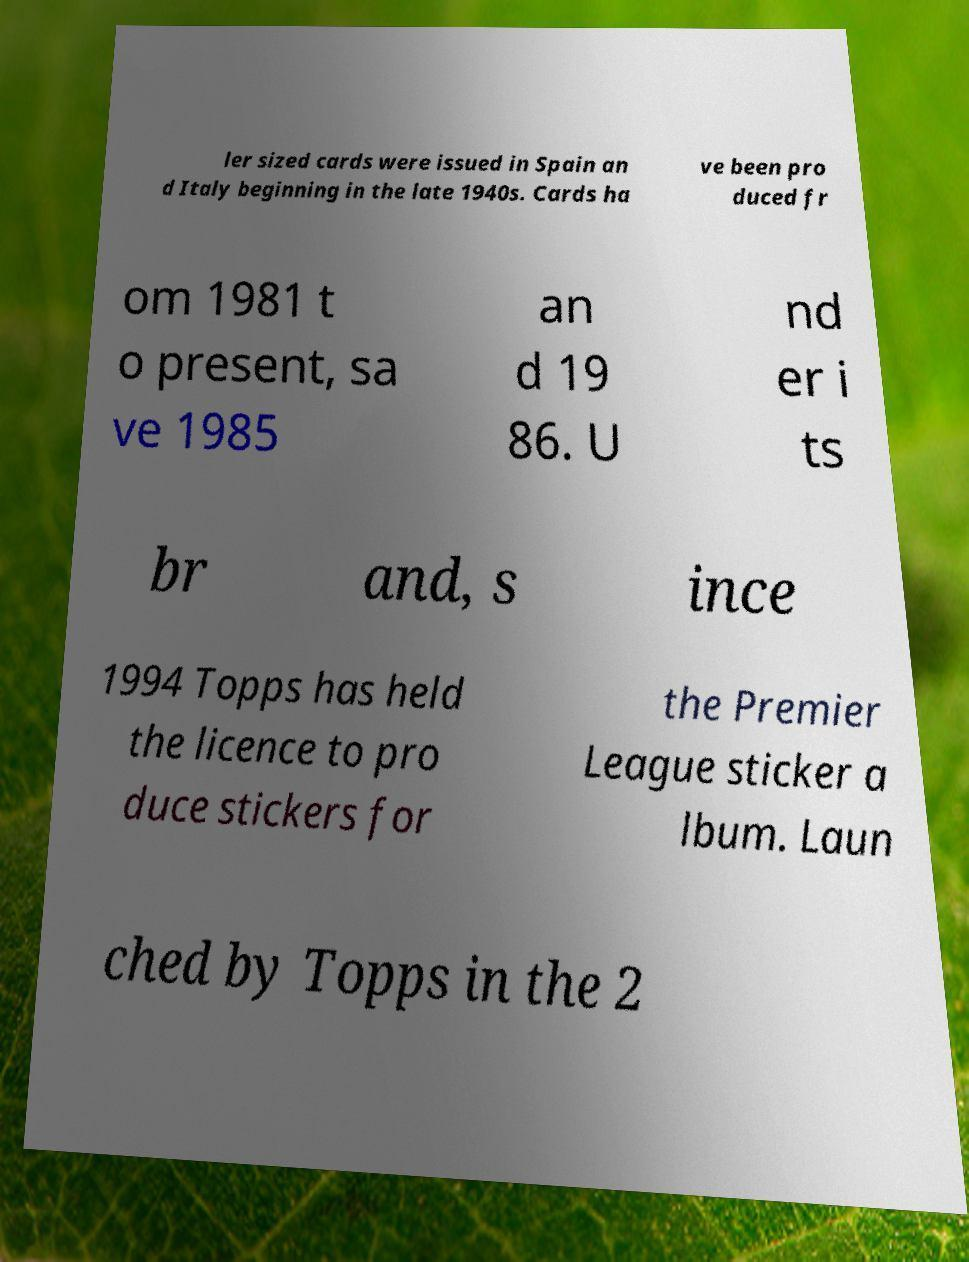Can you read and provide the text displayed in the image?This photo seems to have some interesting text. Can you extract and type it out for me? ler sized cards were issued in Spain an d Italy beginning in the late 1940s. Cards ha ve been pro duced fr om 1981 t o present, sa ve 1985 an d 19 86. U nd er i ts br and, s ince 1994 Topps has held the licence to pro duce stickers for the Premier League sticker a lbum. Laun ched by Topps in the 2 